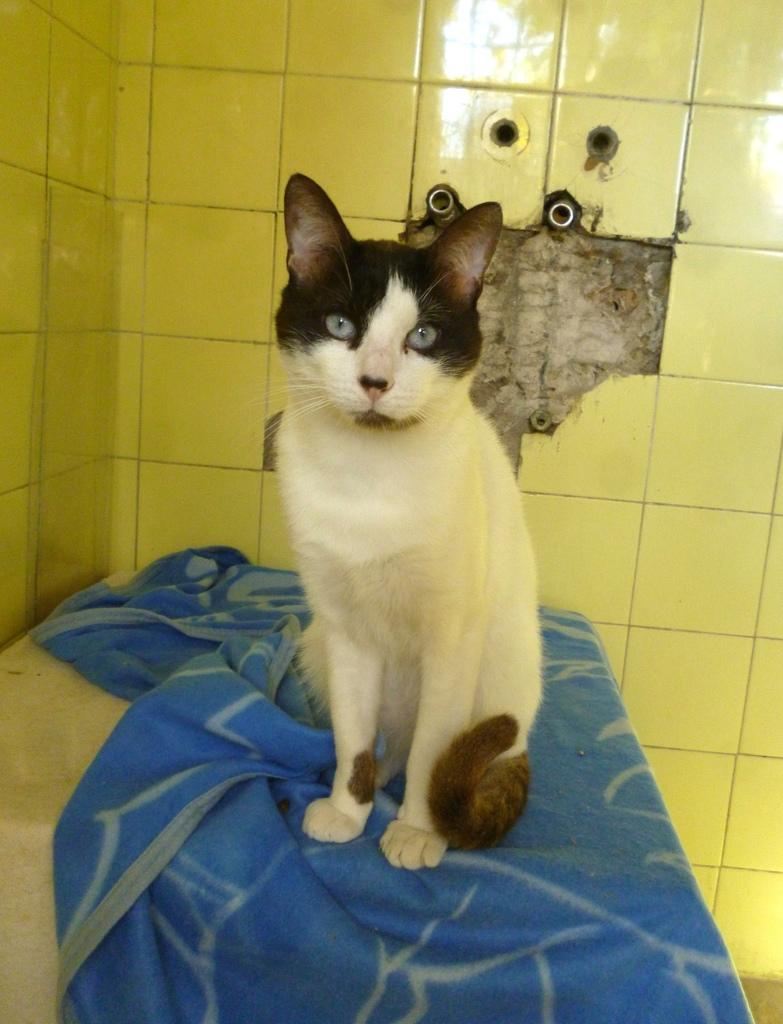What animal can be seen in the image? There is a cat in the image. Where is the cat sitting? The cat is sitting on a blanket. What type of wall is visible in the image? There is a tile wall in the image. What can be observed on the tile wall? There is a reflection on the tile wall. What architectural feature can be seen in the image? There are pipes in a wall in the image. What type of art can be seen on the cat's skin in the image? There is no art visible on the cat's skin in the image. 